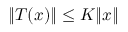<formula> <loc_0><loc_0><loc_500><loc_500>\| T ( x ) \| \leq K \| x \|</formula> 